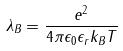Convert formula to latex. <formula><loc_0><loc_0><loc_500><loc_500>\lambda _ { B } = \frac { e ^ { 2 } } { 4 \pi \epsilon _ { 0 } \epsilon _ { r } k _ { B } T }</formula> 